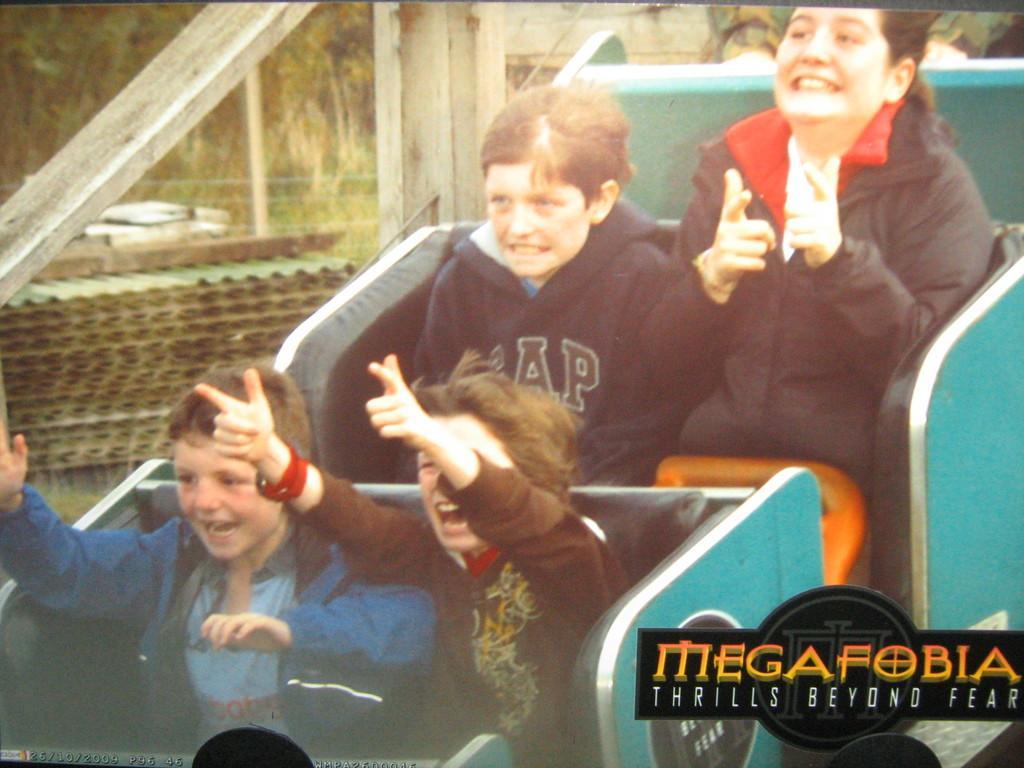Can you describe this image briefly? In this picture we can see four persons on the seats. In the background there are trees. 